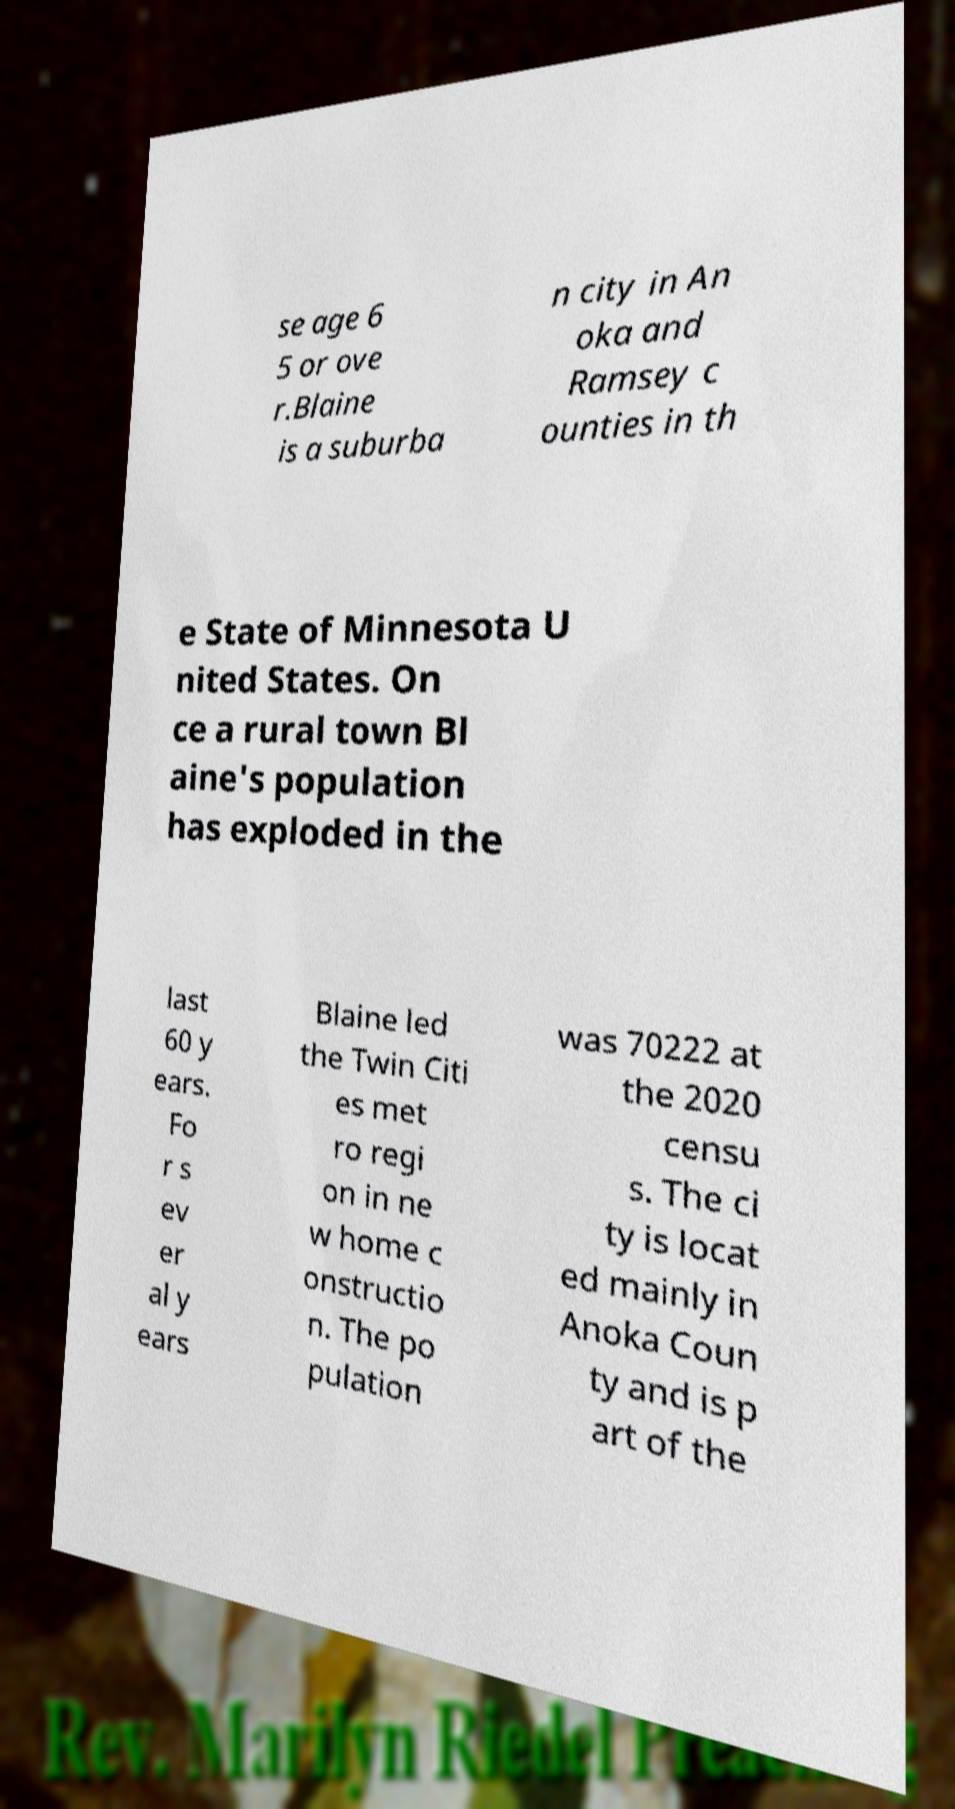For documentation purposes, I need the text within this image transcribed. Could you provide that? se age 6 5 or ove r.Blaine is a suburba n city in An oka and Ramsey c ounties in th e State of Minnesota U nited States. On ce a rural town Bl aine's population has exploded in the last 60 y ears. Fo r s ev er al y ears Blaine led the Twin Citi es met ro regi on in ne w home c onstructio n. The po pulation was 70222 at the 2020 censu s. The ci ty is locat ed mainly in Anoka Coun ty and is p art of the 